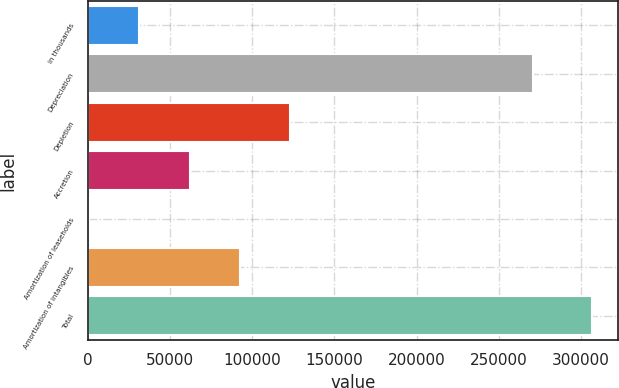Convert chart to OTSL. <chart><loc_0><loc_0><loc_500><loc_500><bar_chart><fcel>in thousands<fcel>Depreciation<fcel>Depletion<fcel>Accretion<fcel>Amortization of leaseholds<fcel>Amortization of intangibles<fcel>Total<nl><fcel>31145.5<fcel>271180<fcel>123133<fcel>61808<fcel>483<fcel>92470.5<fcel>307108<nl></chart> 